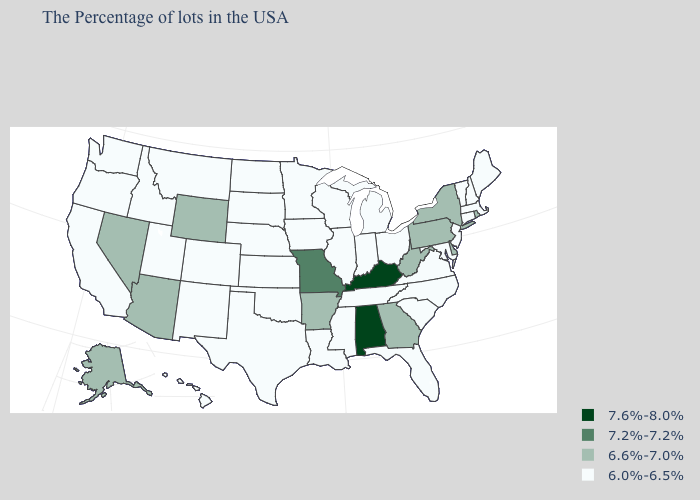Which states have the lowest value in the USA?
Give a very brief answer. Maine, Massachusetts, New Hampshire, Vermont, Connecticut, New Jersey, Maryland, Virginia, North Carolina, South Carolina, Ohio, Florida, Michigan, Indiana, Tennessee, Wisconsin, Illinois, Mississippi, Louisiana, Minnesota, Iowa, Kansas, Nebraska, Oklahoma, Texas, South Dakota, North Dakota, Colorado, New Mexico, Utah, Montana, Idaho, California, Washington, Oregon, Hawaii. What is the value of Oregon?
Give a very brief answer. 6.0%-6.5%. What is the value of Iowa?
Be succinct. 6.0%-6.5%. Which states have the lowest value in the USA?
Short answer required. Maine, Massachusetts, New Hampshire, Vermont, Connecticut, New Jersey, Maryland, Virginia, North Carolina, South Carolina, Ohio, Florida, Michigan, Indiana, Tennessee, Wisconsin, Illinois, Mississippi, Louisiana, Minnesota, Iowa, Kansas, Nebraska, Oklahoma, Texas, South Dakota, North Dakota, Colorado, New Mexico, Utah, Montana, Idaho, California, Washington, Oregon, Hawaii. Does South Carolina have the highest value in the South?
Concise answer only. No. What is the value of California?
Short answer required. 6.0%-6.5%. Name the states that have a value in the range 6.6%-7.0%?
Write a very short answer. Rhode Island, New York, Delaware, Pennsylvania, West Virginia, Georgia, Arkansas, Wyoming, Arizona, Nevada, Alaska. Name the states that have a value in the range 6.0%-6.5%?
Quick response, please. Maine, Massachusetts, New Hampshire, Vermont, Connecticut, New Jersey, Maryland, Virginia, North Carolina, South Carolina, Ohio, Florida, Michigan, Indiana, Tennessee, Wisconsin, Illinois, Mississippi, Louisiana, Minnesota, Iowa, Kansas, Nebraska, Oklahoma, Texas, South Dakota, North Dakota, Colorado, New Mexico, Utah, Montana, Idaho, California, Washington, Oregon, Hawaii. What is the lowest value in the Northeast?
Quick response, please. 6.0%-6.5%. Among the states that border Arizona , does Nevada have the lowest value?
Answer briefly. No. Among the states that border Oklahoma , does Missouri have the highest value?
Write a very short answer. Yes. Among the states that border Connecticut , which have the lowest value?
Short answer required. Massachusetts. Does Hawaii have the lowest value in the West?
Write a very short answer. Yes. Does the first symbol in the legend represent the smallest category?
Short answer required. No. 